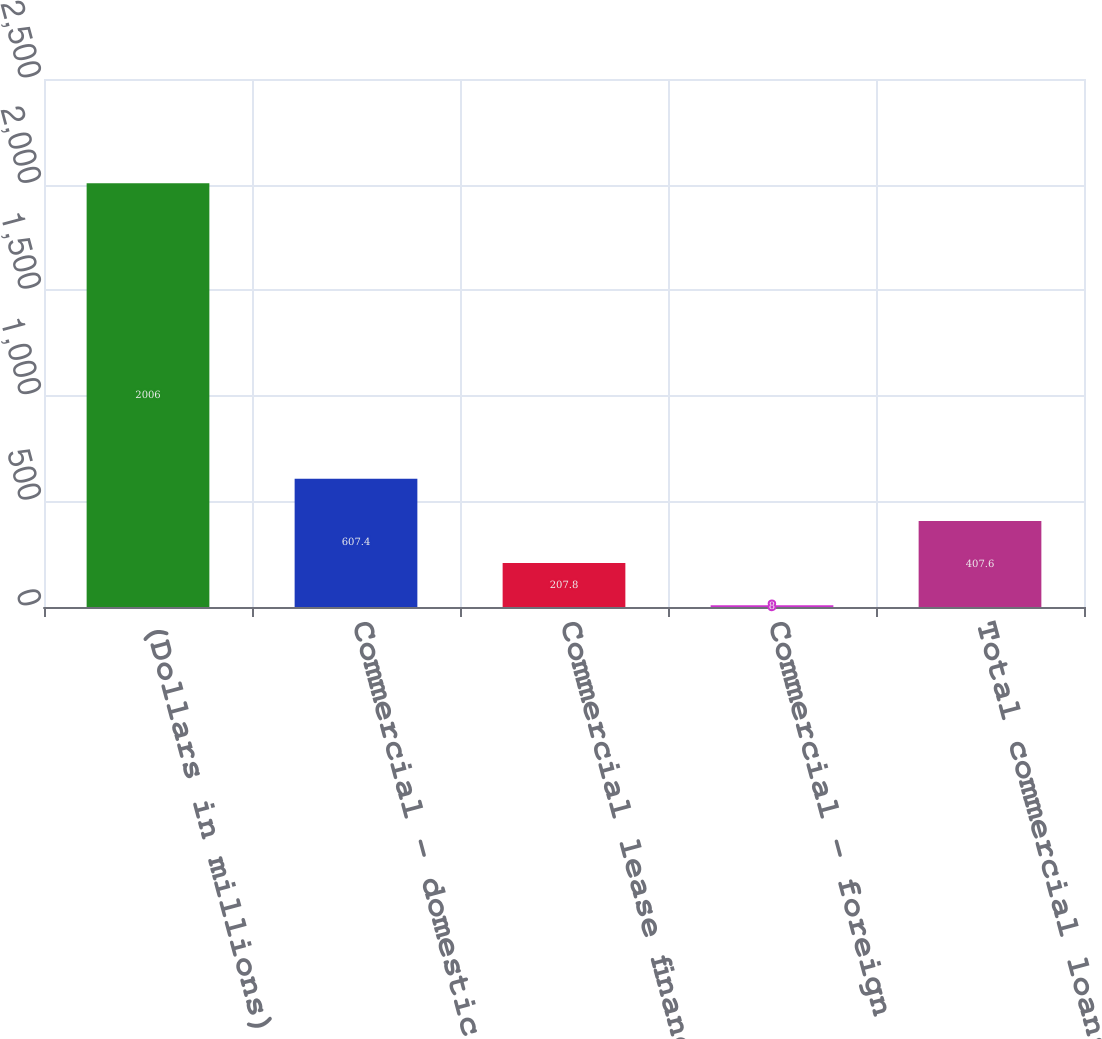Convert chart. <chart><loc_0><loc_0><loc_500><loc_500><bar_chart><fcel>(Dollars in millions)<fcel>Commercial - domestic<fcel>Commercial lease financing<fcel>Commercial - foreign<fcel>Total commercial loans and<nl><fcel>2006<fcel>607.4<fcel>207.8<fcel>8<fcel>407.6<nl></chart> 